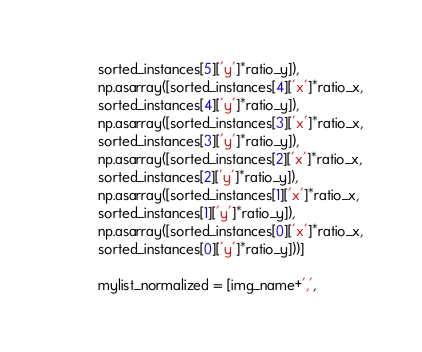<code> <loc_0><loc_0><loc_500><loc_500><_Python_>          sorted_instances[5]['y']*ratio_y]),
          np.asarray([sorted_instances[4]['x']*ratio_x,
          sorted_instances[4]['y']*ratio_y]),
          np.asarray([sorted_instances[3]['x']*ratio_x,
          sorted_instances[3]['y']*ratio_y]),
          np.asarray([sorted_instances[2]['x']*ratio_x,
          sorted_instances[2]['y']*ratio_y]),
          np.asarray([sorted_instances[1]['x']*ratio_x,
          sorted_instances[1]['y']*ratio_y]),
          np.asarray([sorted_instances[0]['x']*ratio_x,
          sorted_instances[0]['y']*ratio_y]))]

          mylist_normalized = [img_name+',',</code> 